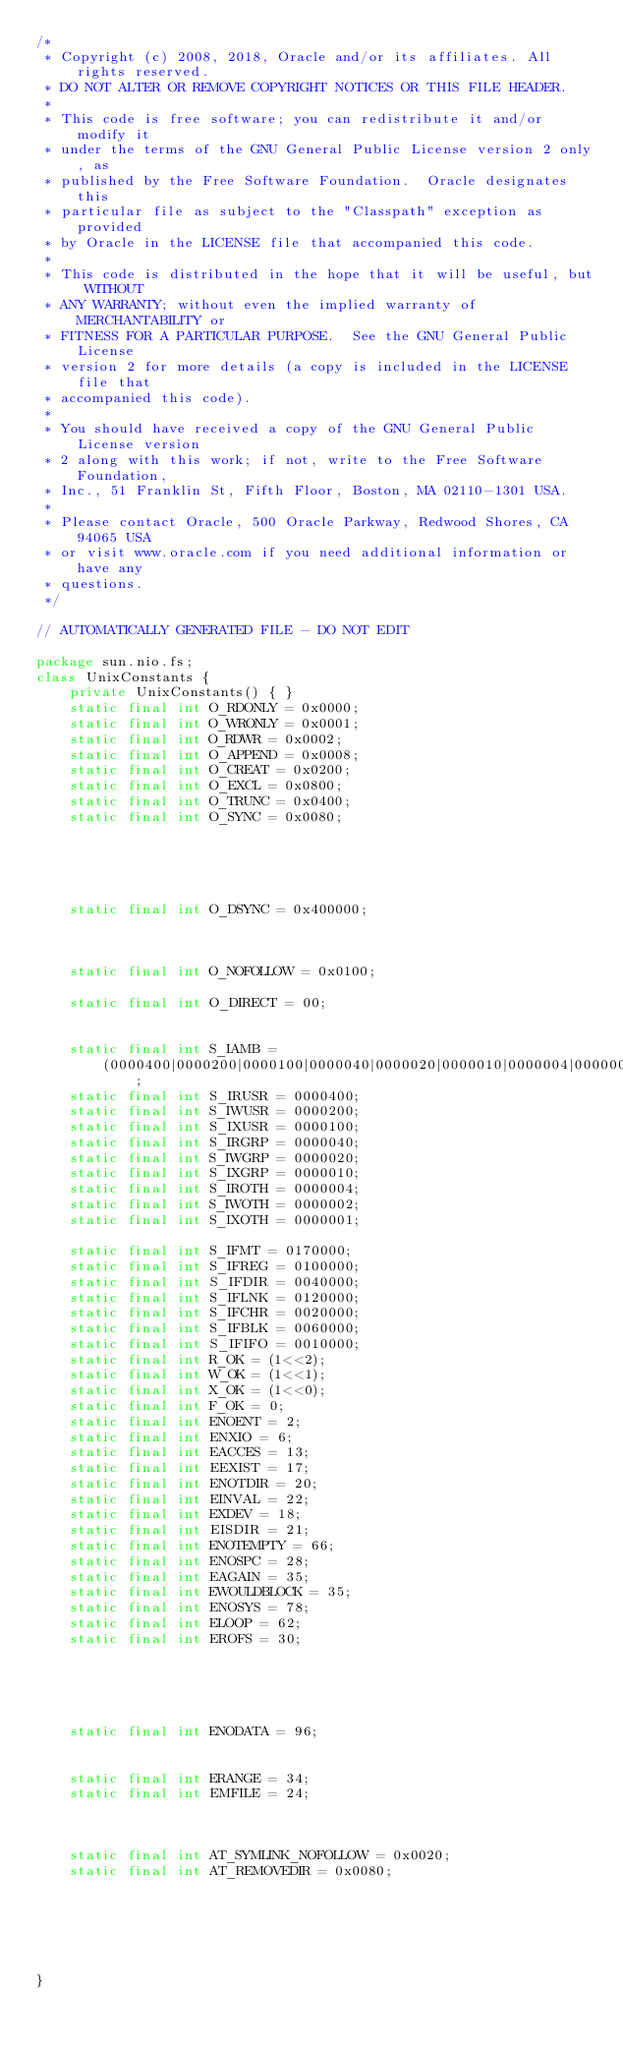<code> <loc_0><loc_0><loc_500><loc_500><_Java_>/*
 * Copyright (c) 2008, 2018, Oracle and/or its affiliates. All rights reserved.
 * DO NOT ALTER OR REMOVE COPYRIGHT NOTICES OR THIS FILE HEADER.
 *
 * This code is free software; you can redistribute it and/or modify it
 * under the terms of the GNU General Public License version 2 only, as
 * published by the Free Software Foundation.  Oracle designates this
 * particular file as subject to the "Classpath" exception as provided
 * by Oracle in the LICENSE file that accompanied this code.
 *
 * This code is distributed in the hope that it will be useful, but WITHOUT
 * ANY WARRANTY; without even the implied warranty of MERCHANTABILITY or
 * FITNESS FOR A PARTICULAR PURPOSE.  See the GNU General Public License
 * version 2 for more details (a copy is included in the LICENSE file that
 * accompanied this code).
 *
 * You should have received a copy of the GNU General Public License version
 * 2 along with this work; if not, write to the Free Software Foundation,
 * Inc., 51 Franklin St, Fifth Floor, Boston, MA 02110-1301 USA.
 *
 * Please contact Oracle, 500 Oracle Parkway, Redwood Shores, CA 94065 USA
 * or visit www.oracle.com if you need additional information or have any
 * questions.
 */

// AUTOMATICALLY GENERATED FILE - DO NOT EDIT

package sun.nio.fs;
class UnixConstants {
    private UnixConstants() { }
    static final int O_RDONLY = 0x0000;
    static final int O_WRONLY = 0x0001;
    static final int O_RDWR = 0x0002;
    static final int O_APPEND = 0x0008;
    static final int O_CREAT = 0x0200;
    static final int O_EXCL = 0x0800;
    static final int O_TRUNC = 0x0400;
    static final int O_SYNC = 0x0080;





    static final int O_DSYNC = 0x400000;



    static final int O_NOFOLLOW = 0x0100;

    static final int O_DIRECT = 00;


    static final int S_IAMB =
        (0000400|0000200|0000100|0000040|0000020|0000010|0000004|0000002|0000001);
    static final int S_IRUSR = 0000400;
    static final int S_IWUSR = 0000200;
    static final int S_IXUSR = 0000100;
    static final int S_IRGRP = 0000040;
    static final int S_IWGRP = 0000020;
    static final int S_IXGRP = 0000010;
    static final int S_IROTH = 0000004;
    static final int S_IWOTH = 0000002;
    static final int S_IXOTH = 0000001;

    static final int S_IFMT = 0170000;
    static final int S_IFREG = 0100000;
    static final int S_IFDIR = 0040000;
    static final int S_IFLNK = 0120000;
    static final int S_IFCHR = 0020000;
    static final int S_IFBLK = 0060000;
    static final int S_IFIFO = 0010000;
    static final int R_OK = (1<<2);
    static final int W_OK = (1<<1);
    static final int X_OK = (1<<0);
    static final int F_OK = 0;
    static final int ENOENT = 2;
    static final int ENXIO = 6;
    static final int EACCES = 13;
    static final int EEXIST = 17;
    static final int ENOTDIR = 20;
    static final int EINVAL = 22;
    static final int EXDEV = 18;
    static final int EISDIR = 21;
    static final int ENOTEMPTY = 66;
    static final int ENOSPC = 28;
    static final int EAGAIN = 35;
    static final int EWOULDBLOCK = 35;
    static final int ENOSYS = 78;
    static final int ELOOP = 62;
    static final int EROFS = 30;





    static final int ENODATA = 96;


    static final int ERANGE = 34;
    static final int EMFILE = 24;



    static final int AT_SYMLINK_NOFOLLOW = 0x0020;
    static final int AT_REMOVEDIR = 0x0080;






}
</code> 